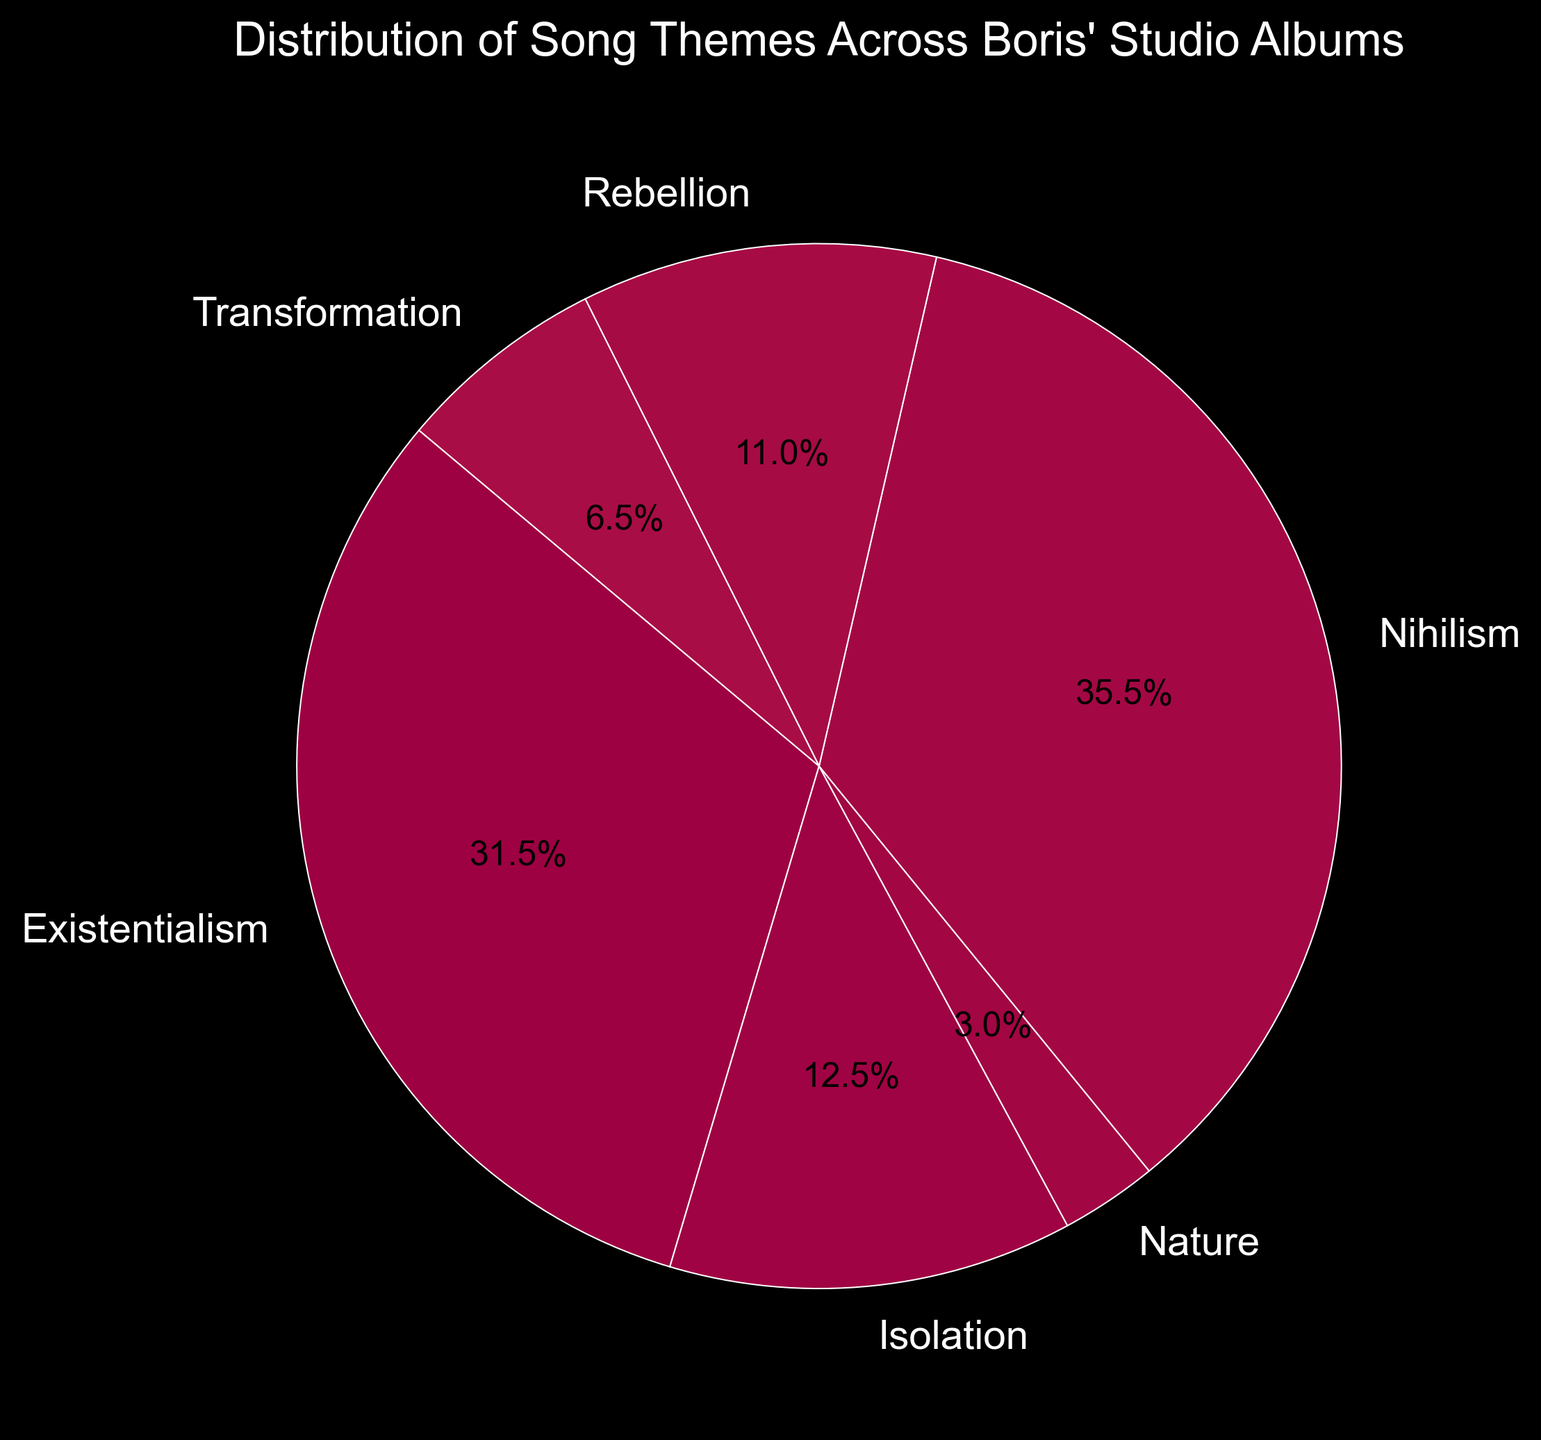What is the most prominent theme across Boris' studio albums? By looking at the pie chart, the largest section represents the theme 'Nihilism' in terms of its percentage contribution.
Answer: Nihilism How does the percentage of 'Existentialism' compare to 'Nihilism'? From the pie chart, the slices for 'Existentialism' and 'Nihilism' can be compared by their visual sizes. The 'Nihilism' slice is slightly larger than 'Existentialism'.
Answer: Nihilism is greater Which theme is represented by the smallest percentage? Visually, the smallest slice in the pie chart corresponds to 'Nature.'
Answer: Nature What is the combined percentage of 'Rebellion' and 'Transformation'? Adding the percentages of 'Rebellion' and 'Transformation' from the pie chart gives the combined value. 'Rebellion' is 15.7% and 'Transformation' is 10.8%. Thus, 15.7 + 10.8 = 26.5%.
Answer: 26.5% Which theme contributes more, 'Isolation' or 'Transformation'? By comparing the sizes of 'Isolation' and 'Transformation' slices in the pie chart, 'Isolation' appears larger.
Answer: Isolation How much more is the 'Nihilism' percentage in comparison to 'Nature'? The percentage of 'Nihilism' from the pie chart is 36.1% and 'Nature' is 4.2%. Subtracting these, 36.1 - 4.2 = 31.9%.
Answer: 31.9% What are the visual attributes of the theme 'Existentialism' in the pie chart? The 'Existentialism' theme is represented by a section of the pie chart with a specific color, size, and a percentage label of 34.1%.
Answer: 34.1% Which theme's slice is visually almost the same size as 'Rebellion'? Observing the pie chart, 'Nihilism' appears to be almost the same size as 'Rebellion' slice.
Answer: Nihilism How does 'Existentialism' compare to the combined percentage of 'Rebellion' and 'Nature'? 'Existentialism' has a percentage of 34.1% while the combined percentage of 'Rebellion' (15.7%) and 'Nature' (4.2%) is 19.9%. So, 34.1% > 19.9%.
Answer: Greater Is the percentage for 'Nihilism' greater than the combined percentage for 'Isolation' and 'Nature'? 'Nihilism' is 36.1%. The combined percentage for 'Isolation' (16.1%) and 'Nature' (4.2%) is 20.3%. 36.1% > 20.3%.
Answer: Yes 